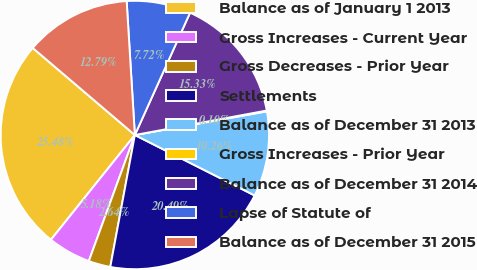Convert chart. <chart><loc_0><loc_0><loc_500><loc_500><pie_chart><fcel>Balance as of January 1 2013<fcel>Gross Increases - Current Year<fcel>Gross Decreases - Prior Year<fcel>Settlements<fcel>Balance as of December 31 2013<fcel>Gross Increases - Prior Year<fcel>Balance as of December 31 2014<fcel>Lapse of Statute of<fcel>Balance as of December 31 2015<nl><fcel>25.48%<fcel>5.18%<fcel>2.64%<fcel>20.49%<fcel>10.26%<fcel>0.1%<fcel>15.33%<fcel>7.72%<fcel>12.79%<nl></chart> 